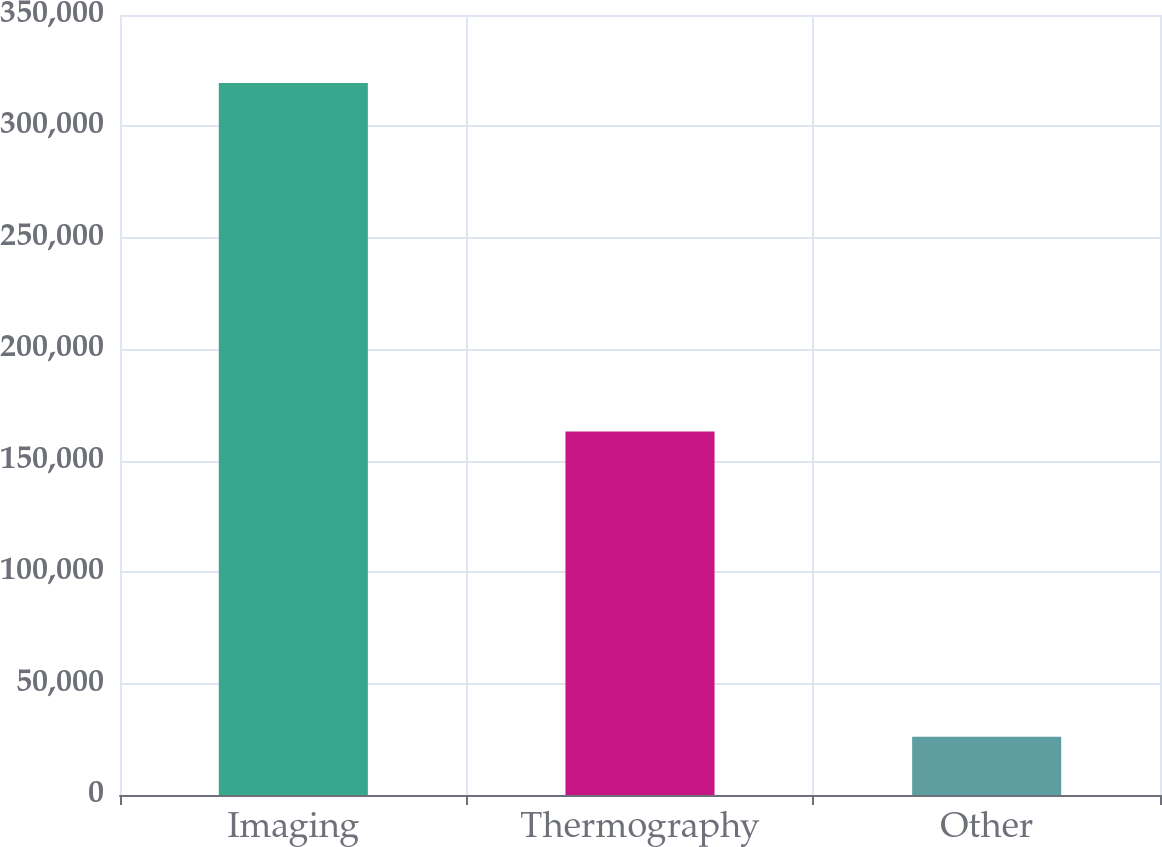<chart> <loc_0><loc_0><loc_500><loc_500><bar_chart><fcel>Imaging<fcel>Thermography<fcel>Other<nl><fcel>319509<fcel>163142<fcel>26107<nl></chart> 